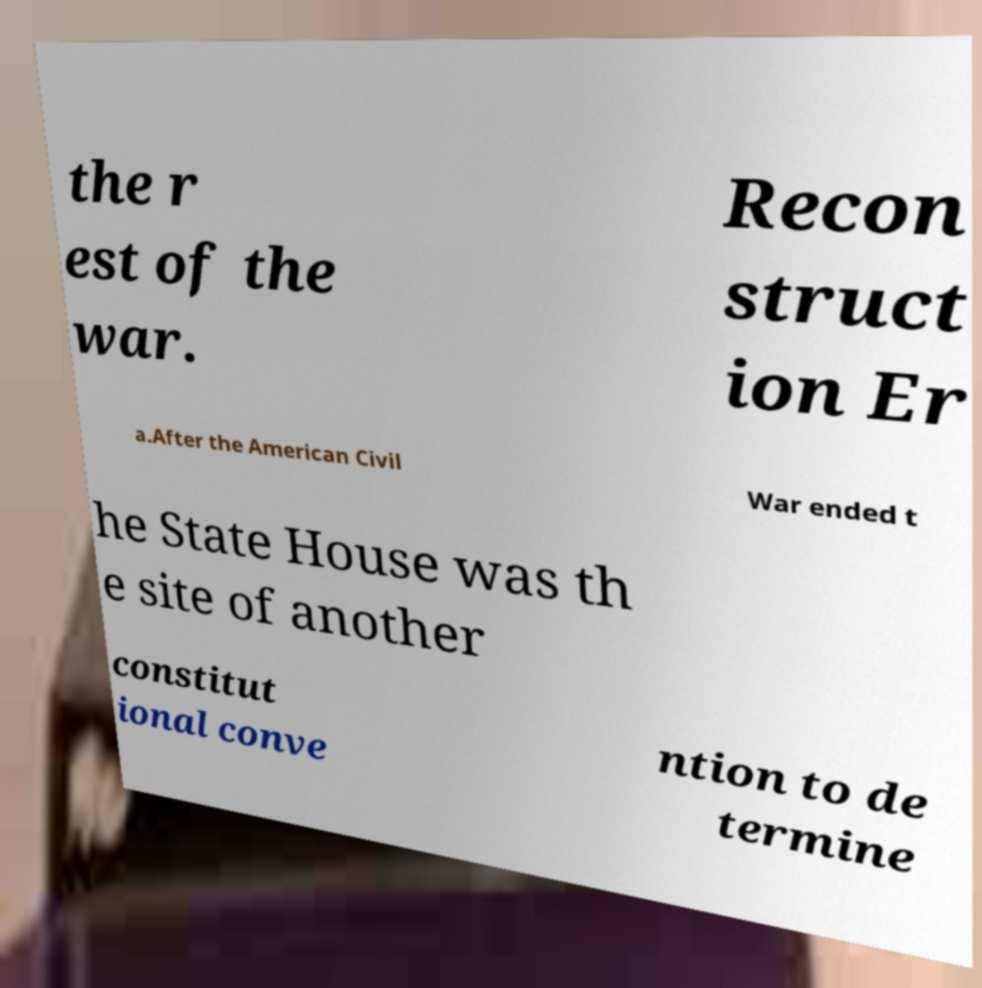What messages or text are displayed in this image? I need them in a readable, typed format. the r est of the war. Recon struct ion Er a.After the American Civil War ended t he State House was th e site of another constitut ional conve ntion to de termine 